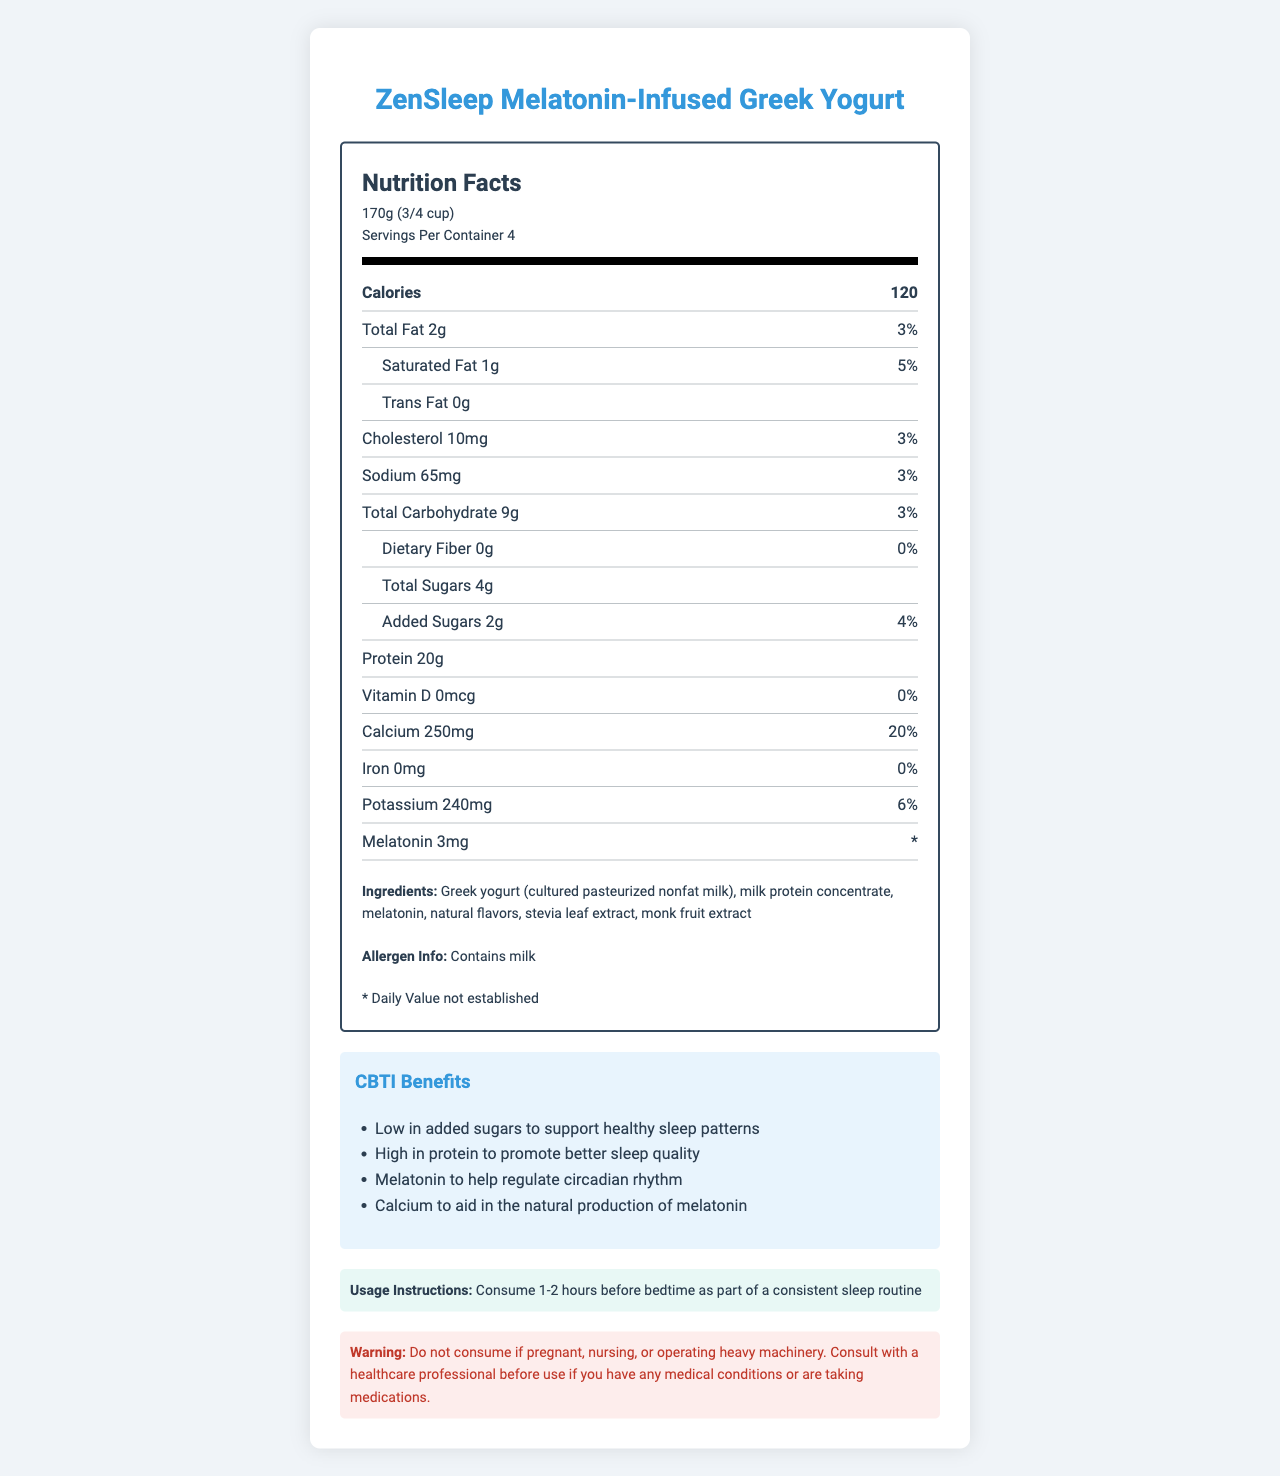what is the serving size of ZenSleep Melatonin-Infused Greek Yogurt? The serving size is mentioned at the top of the Nutrition Facts label in the visual document.
Answer: 170g (3/4 cup) How many calories are there per serving? The number of calories per serving is listed directly under "Calories" in the Nutrition Facts label.
Answer: 120 What is the total fat content per serving? The total fat content per serving is mentioned under the "Total Fat" section in the visual.
Answer: 2g How much protein does it contain per serving? The amount of protein per serving is documented in the "Protein" section.
Answer: 20g How many servings are there per container? The number of servings per container is listed towards the top of the label next to serving size.
Answer: 4 What is the daily value percentage for saturated fat? The daily value percentage for saturated fat is listed under the "Saturated Fat" section.
Answer: 5% Does the yogurt contain any trans fat? The Nutrition Facts label lists "Trans Fat 0g", indicating that it does not contain trans fat.
Answer: No How much melatonin is in each serving? The amount of melatonin per serving is indicated in the "Melatonin" section.
Answer: 3mg What are the added sugars, and what percentage of daily value do they represent? The information is listed under the "Added Sugars" section.
Answer: 2g, 4% Which of the following ingredients are natural sweeteners in the yogurt? A. Stevia leaf extract B. Monk fruit extract C. High fructose corn syrup D. Both A and B The ingredients list includes "stevia leaf extract" and "monk fruit extract" as natural sweeteners, but not high fructose corn syrup.
Answer: D. Both A and B What is the calcium content and its daily value percentage? A. 200mg, 15% B. 240mg, 18% C. 250mg, 20% D. 100mg, 10% The calcium content and its daily value percentage are listed under the "Calcium" section of the Nutrition Facts label.
Answer: C. 250mg, 20% Is there any iron content in the yogurt? The Nutrition Facts label shows "Iron 0mg" and "0%" daily value, meaning it does not contain iron.
Answer: No What are some CBTI benefits of this yogurt as mentioned in the document? The CBTI benefits are listed in a defined section towards the bottom of the document.
Answer: "Low in added sugars to support healthy sleep patterns", "High in protein to promote better sleep quality", "Melatonin to help regulate circadian rhythm", "Calcium to aid in the natural production of melatonin" What should you do before consuming this yogurt? The warning section gives specific advice on consulting a healthcare professional under certain conditions.
Answer: Consult with a healthcare professional if you have any medical conditions or are taking medications. Summarize the main idea of the document. The document is designed to inform consumers about the yogurt's health benefits, particularly its low sugar content, high protein, melatonin, and calcium, and how it supports better sleep, along with providing instructions and warnings for safe consumption.
Answer: The document provides comprehensive information about ZenSleep Melatonin-Infused Greek Yogurt, including its nutritional content, ingredients, CBTI benefits, usage instructions, and warnings. How long before bedtime should you consume this yogurt? The usage instructions indicate consuming the yogurt 1-2 hours before bedtime as part of a consistent sleep routine.
Answer: 1-2 hours before bedtime What are the total carbohydrates per serving, and what percentage of the daily value do they represent? The total carbohydrate content and its daily value percentage are listed under the "Total Carbohydrate" section in the Nutrition Facts label.
Answer: 9g, 3% Can the document tell you if this yogurt helps with weight loss? The document does not provide any information or claims related to weight loss.
Answer: Cannot be determined 